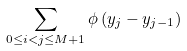Convert formula to latex. <formula><loc_0><loc_0><loc_500><loc_500>\sum _ { 0 \leq i < j \leq M + 1 } \phi \left ( y _ { j } - y _ { j - 1 } \right )</formula> 